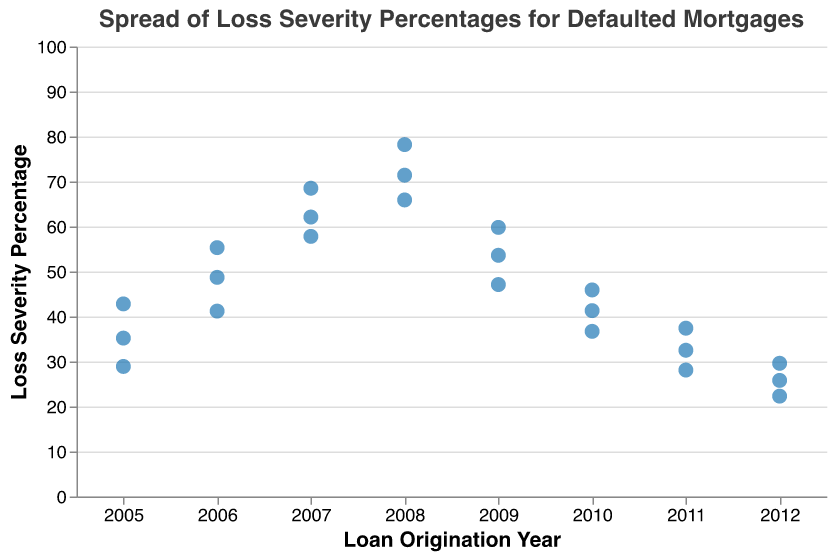What is the title of the plot? The title is displayed at the top of the plot. It reads “Spread of Loss Severity Percentages for Defaulted Mortgages”
Answer: Spread of Loss Severity Percentages for Defaulted Mortgages Which year has the highest loss severity percentage? By looking at the vertical spread of points, 2008 has the highest loss severity percentage at 78.2%.
Answer: 2008 What is the lowest loss severity percentage in 2012? For 2012, the lowest data point in the vertical spread indicates a loss severity percentage of 22.3%.
Answer: 22.3% How many data points represent the year 2007? Count the number of individual points plotted vertically for the year 2007. There are 3 data points.
Answer: 3 Which year has the most concentrated spread of loss severity percentages? By observing the density of points along the vertical axis per year, 2012 appears to have the most concentrated spread.
Answer: 2012 What is the average loss severity percentage for the year 2009? Sum the loss severity percentages for the year 2009 (53.6 + 47.1 + 59.8 = 160.5) and divide by the number of data points (3). The average is 160.5 / 3 ≈ 53.5%.
Answer: 53.5% Compare the loss severity percentage ranges of 2006 and 2010. Which year shows a wider range? For 2006, the range is from 41.2% to 55.3%, giving a range of 14.1. For 2010, the range is from 36.7% to 45.9%, giving a range of 9.2. Thus, 2006 has a wider range.
Answer: 2006 Which year has a lower range of loss severity percentages, 2005 or 2011? For 2005, the range is from 28.9% to 42.8% (42.8 - 28.9 = 13.9). For 2011, the range is from 28.1% to 37.4% (37.4 - 28.1 = 9.3). 2011 has a lower range.
Answer: 2011 How does the loss severity percentage in 2008 compare to that in 2007? The highest value in 2008 (78.2%) is higher than the highest value in 2007 (68.5%). The lowest value in 2008 (65.9%) is also higher than the lowest value in 2007 (57.8%). Overall, 2008 has higher loss severity percentages compared to 2007.
Answer: 2008 has higher percentages What's the median value of the loss severity percentage for 2010? The values for 2010 are 36.7%, 41.3%, and 45.9%. The median of these values (middle value when ordered) is 41.3%.
Answer: 41.3% 